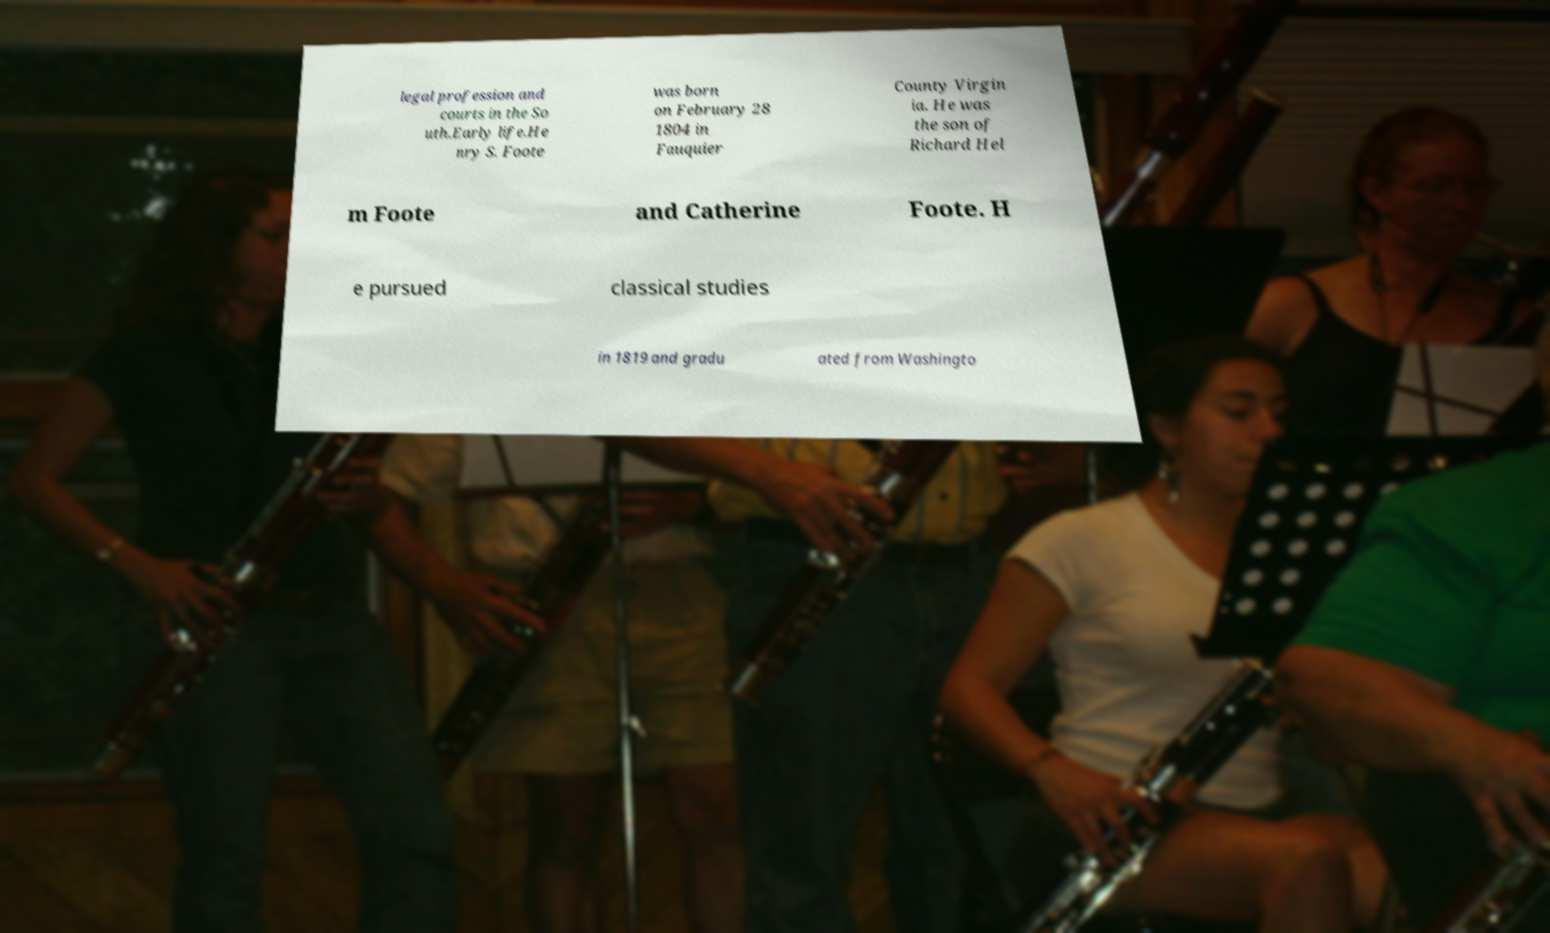Could you extract and type out the text from this image? legal profession and courts in the So uth.Early life.He nry S. Foote was born on February 28 1804 in Fauquier County Virgin ia. He was the son of Richard Hel m Foote and Catherine Foote. H e pursued classical studies in 1819 and gradu ated from Washingto 